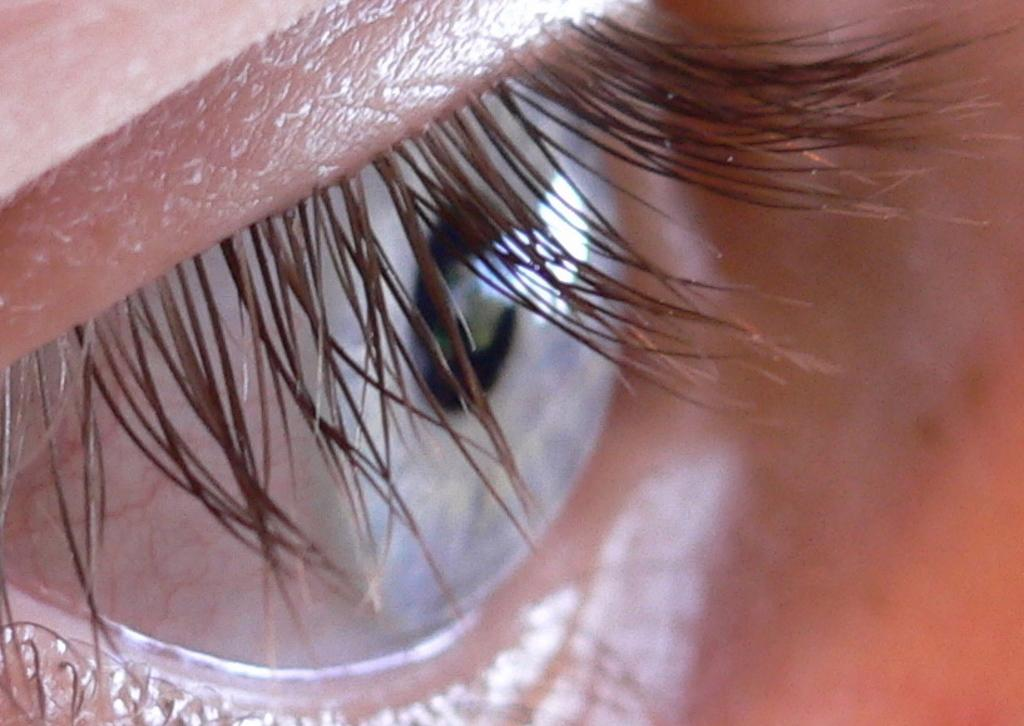What is the main subject of the image? The main subject of the image is a person's eye. Can you describe the background of the image? The background of the image is blurry. What type of list can be seen in the image? There is no list present in the image; it features a person's eye and a blurry background. What is the tax rate for the square in the image? There is no square or tax rate mentioned in the image; it only shows a person's eye and a blurry background. 